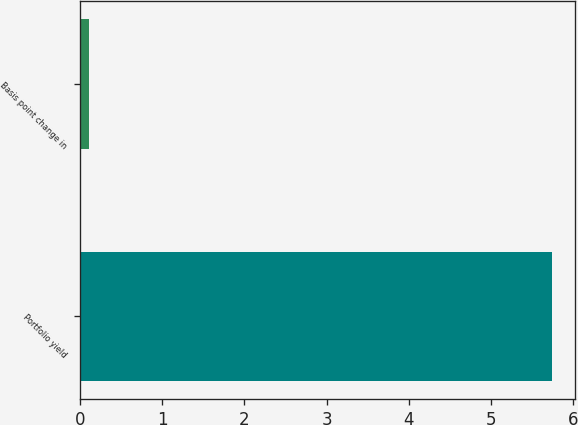Convert chart. <chart><loc_0><loc_0><loc_500><loc_500><bar_chart><fcel>Portfolio yield<fcel>Basis point change in<nl><fcel>5.74<fcel>0.11<nl></chart> 